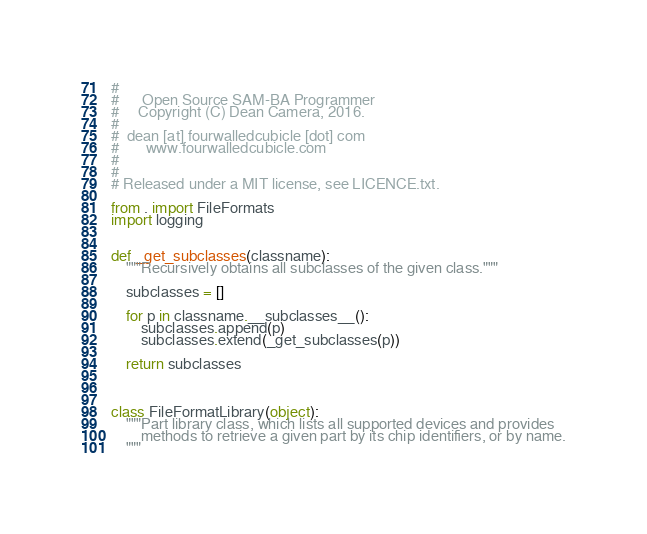Convert code to text. <code><loc_0><loc_0><loc_500><loc_500><_Python_>#
#      Open Source SAM-BA Programmer
#     Copyright (C) Dean Camera, 2016.
#
#  dean [at] fourwalledcubicle [dot] com
#       www.fourwalledcubicle.com
#
#
# Released under a MIT license, see LICENCE.txt.

from . import FileFormats
import logging


def _get_subclasses(classname):
	"""Recursively obtains all subclasses of the given class."""

	subclasses = []

	for p in classname.__subclasses__():
		subclasses.append(p)
		subclasses.extend(_get_subclasses(p))

	return subclasses



class FileFormatLibrary(object):
	"""Part library class, which lists all supported devices and provides
		methods to retrieve a given part by its chip identifiers, or by name.
	"""
</code> 